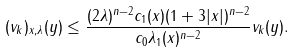<formula> <loc_0><loc_0><loc_500><loc_500>( v _ { k } ) _ { x , \lambda } ( y ) \leq \frac { ( 2 \lambda ) ^ { n - 2 } c _ { 1 } ( x ) ( 1 + 3 | x | ) ^ { n - 2 } } { c _ { 0 } \lambda _ { 1 } ( x ) ^ { n - 2 } } v _ { k } ( y ) .</formula> 